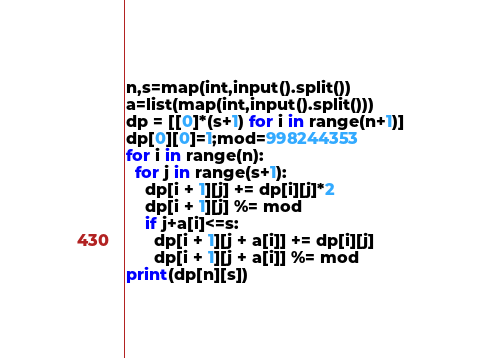<code> <loc_0><loc_0><loc_500><loc_500><_Cython_>n,s=map(int,input().split())
a=list(map(int,input().split()))
dp = [[0]*(s+1) for i in range(n+1)]
dp[0][0]=1;mod=998244353
for i in range(n):
  for j in range(s+1):
    dp[i + 1][j] += dp[i][j]*2
    dp[i + 1][j] %= mod
    if j+a[i]<=s:
      dp[i + 1][j + a[i]] += dp[i][j]
      dp[i + 1][j + a[i]] %= mod
print(dp[n][s])</code> 